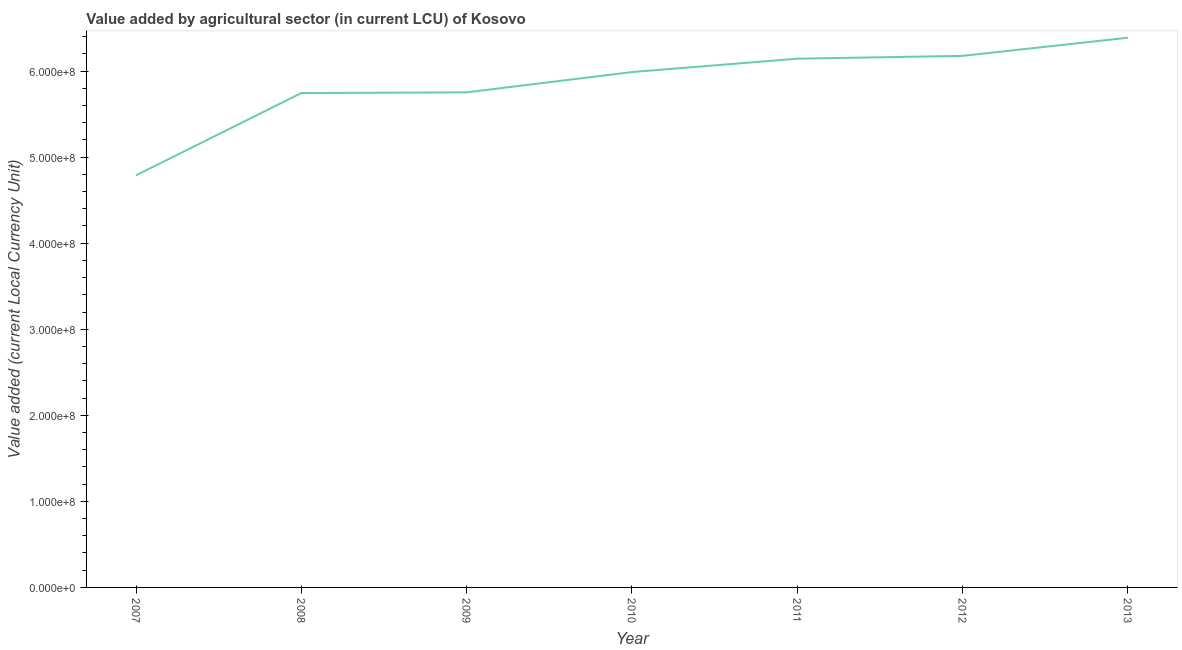What is the value added by agriculture sector in 2010?
Keep it short and to the point. 5.99e+08. Across all years, what is the maximum value added by agriculture sector?
Offer a terse response. 6.39e+08. Across all years, what is the minimum value added by agriculture sector?
Offer a terse response. 4.79e+08. In which year was the value added by agriculture sector maximum?
Offer a terse response. 2013. What is the sum of the value added by agriculture sector?
Provide a short and direct response. 4.10e+09. What is the difference between the value added by agriculture sector in 2007 and 2012?
Your answer should be compact. -1.39e+08. What is the average value added by agriculture sector per year?
Your answer should be compact. 5.85e+08. What is the median value added by agriculture sector?
Offer a terse response. 5.99e+08. In how many years, is the value added by agriculture sector greater than 320000000 LCU?
Offer a terse response. 7. What is the ratio of the value added by agriculture sector in 2009 to that in 2013?
Make the answer very short. 0.9. Is the value added by agriculture sector in 2010 less than that in 2011?
Your answer should be compact. Yes. What is the difference between the highest and the second highest value added by agriculture sector?
Offer a terse response. 2.11e+07. What is the difference between the highest and the lowest value added by agriculture sector?
Make the answer very short. 1.60e+08. In how many years, is the value added by agriculture sector greater than the average value added by agriculture sector taken over all years?
Offer a very short reply. 4. Does the graph contain any zero values?
Provide a succinct answer. No. What is the title of the graph?
Offer a terse response. Value added by agricultural sector (in current LCU) of Kosovo. What is the label or title of the X-axis?
Make the answer very short. Year. What is the label or title of the Y-axis?
Make the answer very short. Value added (current Local Currency Unit). What is the Value added (current Local Currency Unit) of 2007?
Keep it short and to the point. 4.79e+08. What is the Value added (current Local Currency Unit) in 2008?
Provide a succinct answer. 5.74e+08. What is the Value added (current Local Currency Unit) in 2009?
Your answer should be compact. 5.75e+08. What is the Value added (current Local Currency Unit) of 2010?
Provide a short and direct response. 5.99e+08. What is the Value added (current Local Currency Unit) of 2011?
Your answer should be compact. 6.14e+08. What is the Value added (current Local Currency Unit) of 2012?
Your response must be concise. 6.18e+08. What is the Value added (current Local Currency Unit) of 2013?
Provide a succinct answer. 6.39e+08. What is the difference between the Value added (current Local Currency Unit) in 2007 and 2008?
Your answer should be compact. -9.56e+07. What is the difference between the Value added (current Local Currency Unit) in 2007 and 2009?
Give a very brief answer. -9.64e+07. What is the difference between the Value added (current Local Currency Unit) in 2007 and 2010?
Give a very brief answer. -1.20e+08. What is the difference between the Value added (current Local Currency Unit) in 2007 and 2011?
Your response must be concise. -1.36e+08. What is the difference between the Value added (current Local Currency Unit) in 2007 and 2012?
Your answer should be very brief. -1.39e+08. What is the difference between the Value added (current Local Currency Unit) in 2007 and 2013?
Your answer should be compact. -1.60e+08. What is the difference between the Value added (current Local Currency Unit) in 2008 and 2009?
Ensure brevity in your answer.  -8.00e+05. What is the difference between the Value added (current Local Currency Unit) in 2008 and 2010?
Give a very brief answer. -2.44e+07. What is the difference between the Value added (current Local Currency Unit) in 2008 and 2011?
Your answer should be compact. -3.99e+07. What is the difference between the Value added (current Local Currency Unit) in 2008 and 2012?
Ensure brevity in your answer.  -4.32e+07. What is the difference between the Value added (current Local Currency Unit) in 2008 and 2013?
Give a very brief answer. -6.43e+07. What is the difference between the Value added (current Local Currency Unit) in 2009 and 2010?
Give a very brief answer. -2.36e+07. What is the difference between the Value added (current Local Currency Unit) in 2009 and 2011?
Keep it short and to the point. -3.91e+07. What is the difference between the Value added (current Local Currency Unit) in 2009 and 2012?
Offer a very short reply. -4.24e+07. What is the difference between the Value added (current Local Currency Unit) in 2009 and 2013?
Give a very brief answer. -6.35e+07. What is the difference between the Value added (current Local Currency Unit) in 2010 and 2011?
Your answer should be very brief. -1.55e+07. What is the difference between the Value added (current Local Currency Unit) in 2010 and 2012?
Your answer should be compact. -1.88e+07. What is the difference between the Value added (current Local Currency Unit) in 2010 and 2013?
Make the answer very short. -3.99e+07. What is the difference between the Value added (current Local Currency Unit) in 2011 and 2012?
Give a very brief answer. -3.30e+06. What is the difference between the Value added (current Local Currency Unit) in 2011 and 2013?
Your answer should be compact. -2.44e+07. What is the difference between the Value added (current Local Currency Unit) in 2012 and 2013?
Offer a very short reply. -2.11e+07. What is the ratio of the Value added (current Local Currency Unit) in 2007 to that in 2008?
Keep it short and to the point. 0.83. What is the ratio of the Value added (current Local Currency Unit) in 2007 to that in 2009?
Provide a short and direct response. 0.83. What is the ratio of the Value added (current Local Currency Unit) in 2007 to that in 2010?
Keep it short and to the point. 0.8. What is the ratio of the Value added (current Local Currency Unit) in 2007 to that in 2011?
Your answer should be compact. 0.78. What is the ratio of the Value added (current Local Currency Unit) in 2007 to that in 2012?
Provide a succinct answer. 0.78. What is the ratio of the Value added (current Local Currency Unit) in 2007 to that in 2013?
Ensure brevity in your answer.  0.75. What is the ratio of the Value added (current Local Currency Unit) in 2008 to that in 2011?
Your response must be concise. 0.94. What is the ratio of the Value added (current Local Currency Unit) in 2008 to that in 2012?
Keep it short and to the point. 0.93. What is the ratio of the Value added (current Local Currency Unit) in 2008 to that in 2013?
Your response must be concise. 0.9. What is the ratio of the Value added (current Local Currency Unit) in 2009 to that in 2010?
Ensure brevity in your answer.  0.96. What is the ratio of the Value added (current Local Currency Unit) in 2009 to that in 2011?
Provide a short and direct response. 0.94. What is the ratio of the Value added (current Local Currency Unit) in 2009 to that in 2012?
Offer a terse response. 0.93. What is the ratio of the Value added (current Local Currency Unit) in 2009 to that in 2013?
Make the answer very short. 0.9. What is the ratio of the Value added (current Local Currency Unit) in 2010 to that in 2012?
Offer a terse response. 0.97. What is the ratio of the Value added (current Local Currency Unit) in 2010 to that in 2013?
Give a very brief answer. 0.94. What is the ratio of the Value added (current Local Currency Unit) in 2011 to that in 2012?
Provide a succinct answer. 0.99. What is the ratio of the Value added (current Local Currency Unit) in 2012 to that in 2013?
Make the answer very short. 0.97. 